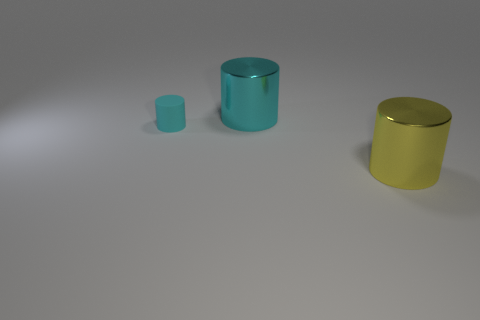Add 3 matte cylinders. How many objects exist? 6 Subtract all large cyan cylinders. Subtract all small cubes. How many objects are left? 2 Add 1 big yellow metallic cylinders. How many big yellow metallic cylinders are left? 2 Add 2 large yellow metallic things. How many large yellow metallic things exist? 3 Subtract 0 cyan balls. How many objects are left? 3 